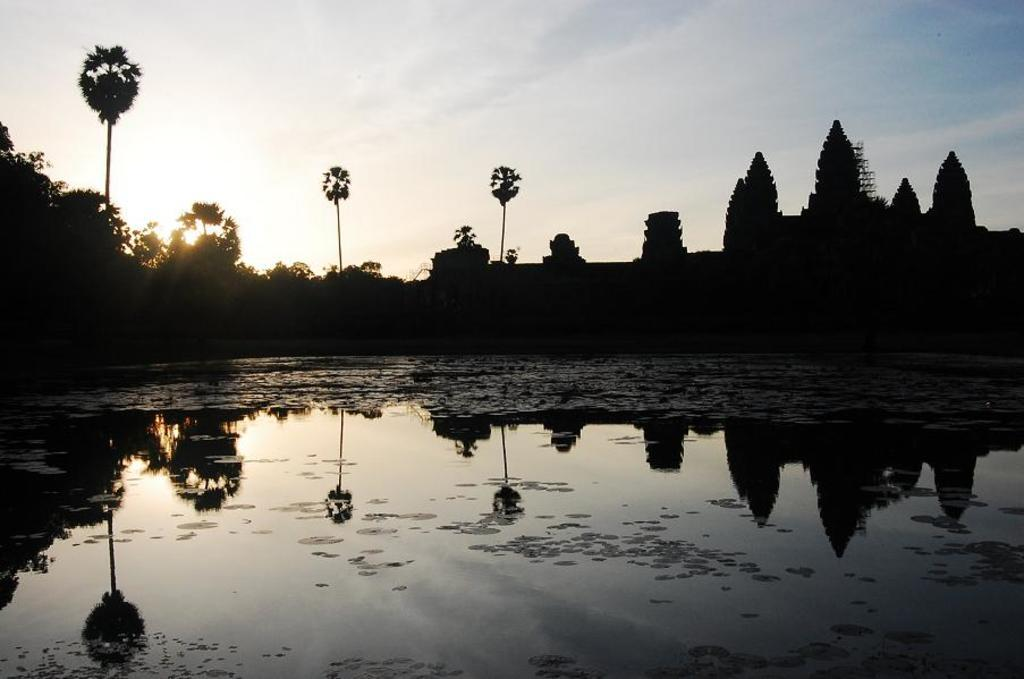What is at the bottom of the image? There is water at the bottom of the image. What can be seen in the middle of the image? There are trees in the middle of the image. What is visible at the top of the image? The sky is visible at the top of the image. What type of structure is on the right side of the image? There appears to be a building on the right side of the image. What type of cream is being used to paint the trees in the image? There is no cream or painting activity present in the image; it features trees in their natural state. What type of can is visible in the image? There is no can present in the image. 